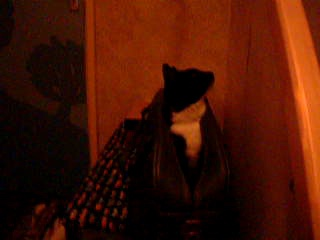Describe the objects in this image and their specific colors. I can see cat in black, maroon, and brown tones and handbag in black, maroon, and brown tones in this image. 